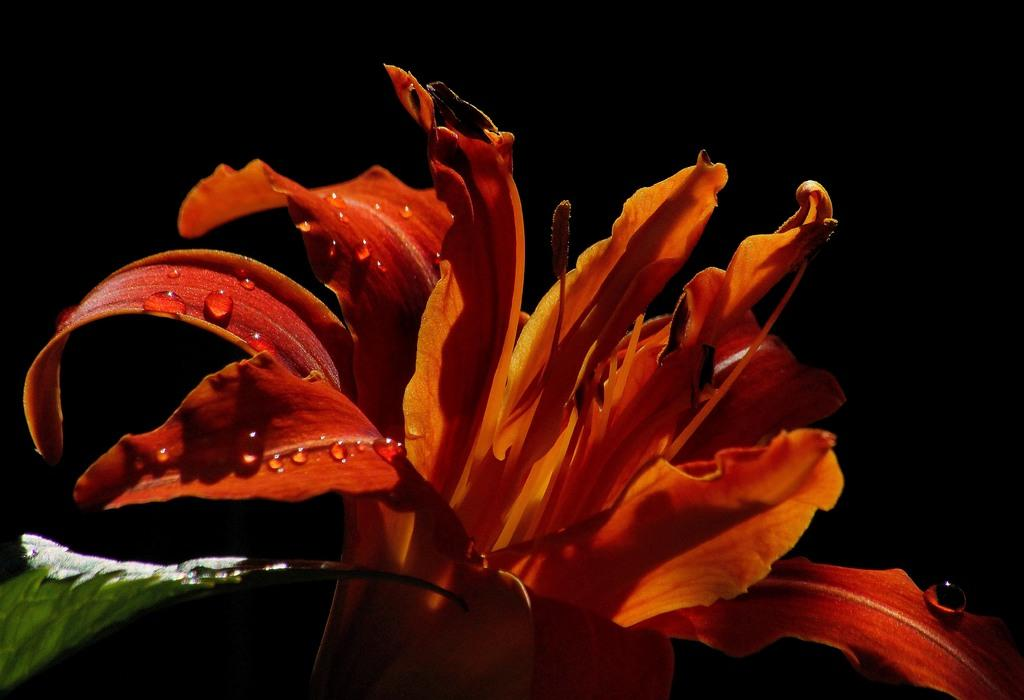What is the main subject of the image? There is a flower in the image. What can be observed on the flower's petals? The flower has water droplets on its petals. How would you describe the background of the image? The background of the image is dark. What else can be seen in the image besides the flower? There is a leaf on the left side of the image. What type of sweater is the flower wearing in the image? There is no sweater present in the image, as flowers do not wear clothing. How does the flower contribute to the death of the person in the image? There is no person present in the image, and the flower is not associated with any death. 